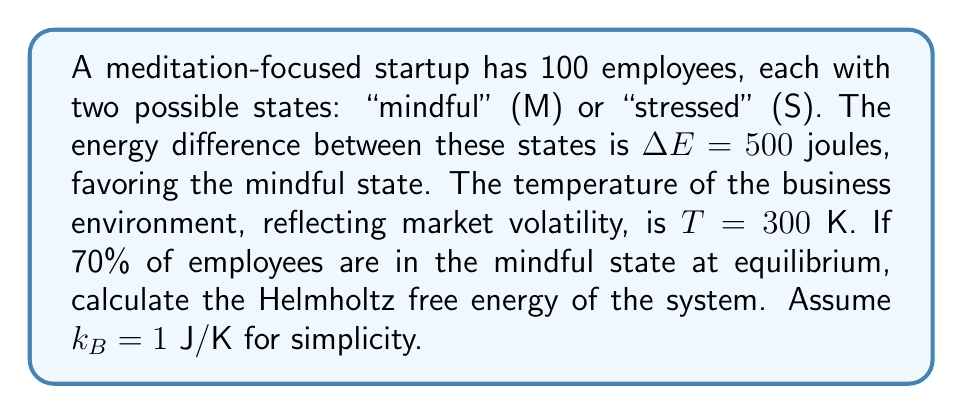Could you help me with this problem? 1) First, we need to calculate the partition function Z:
   $$Z = e^{-E_M/k_BT} + e^{-E_S/k_BT}$$

2) Let $E_M = 0$ and $E_S = \Delta E = 500$ J:
   $$Z = e^0 + e^{-500/300} = 1 + e^{-5/3} \approx 1.5188$$

3) The probability of being in the mindful state is given:
   $$p_M = 0.7 = \frac{e^{-E_M/k_BT}}{Z} = \frac{1}{Z}$$

4) This confirms our calculation of Z:
   $$Z = \frac{1}{p_M} = \frac{1}{0.7} \approx 1.4286$$

5) The Helmholtz free energy F is given by:
   $$F = -k_BT \ln Z$$

6) Substituting the values:
   $$F = -300 \ln(1.4286) \approx -107.31$$ J

7) For 100 employees, the total free energy is:
   $$F_{total} = 100 \times (-107.31) = -10,731$$ J
Answer: -10,731 J 